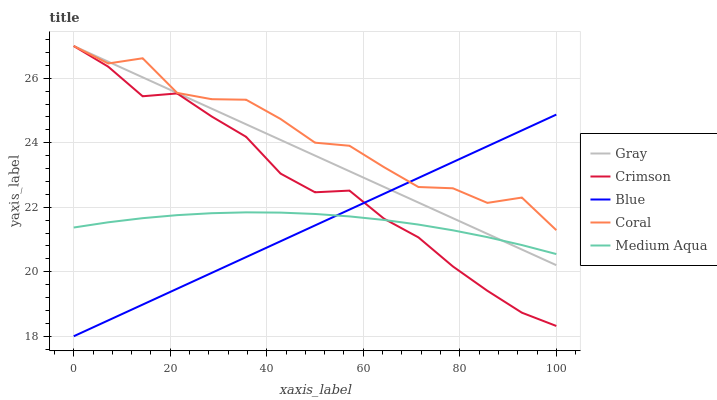Does Gray have the minimum area under the curve?
Answer yes or no. No. Does Gray have the maximum area under the curve?
Answer yes or no. No. Is Coral the smoothest?
Answer yes or no. No. Is Gray the roughest?
Answer yes or no. No. Does Gray have the lowest value?
Answer yes or no. No. Does Medium Aqua have the highest value?
Answer yes or no. No. Is Medium Aqua less than Coral?
Answer yes or no. Yes. Is Coral greater than Medium Aqua?
Answer yes or no. Yes. Does Medium Aqua intersect Coral?
Answer yes or no. No. 